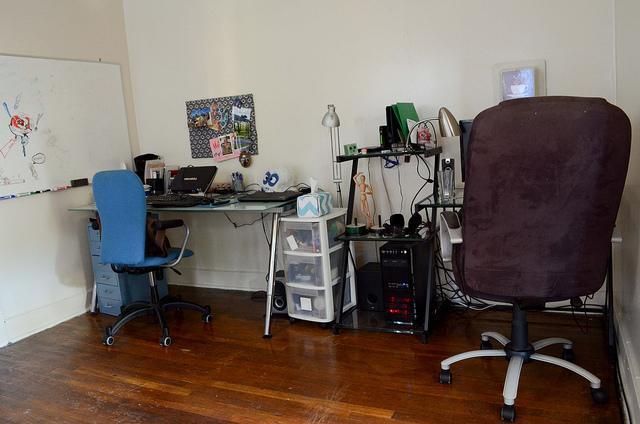How many chairs are there?
Give a very brief answer. 2. 